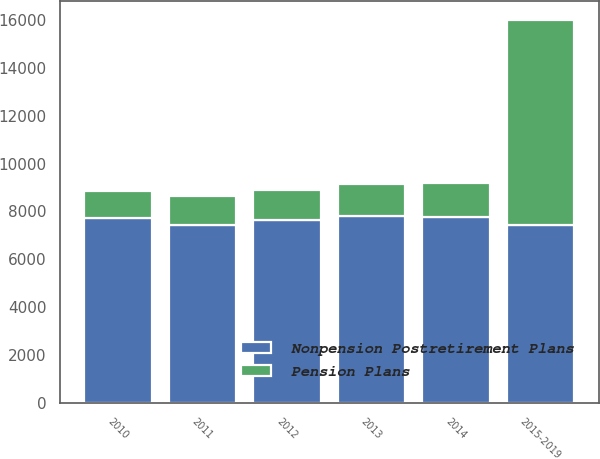<chart> <loc_0><loc_0><loc_500><loc_500><stacked_bar_chart><ecel><fcel>2010<fcel>2011<fcel>2012<fcel>2013<fcel>2014<fcel>2015-2019<nl><fcel>Nonpension Postretirement Plans<fcel>7736<fcel>7434<fcel>7626<fcel>7793<fcel>7771<fcel>7434<nl><fcel>Pension Plans<fcel>1114<fcel>1200<fcel>1274<fcel>1344<fcel>1436<fcel>8552<nl></chart> 